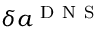<formula> <loc_0><loc_0><loc_500><loc_500>\delta { { a } ^ { D N S } }</formula> 